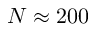<formula> <loc_0><loc_0><loc_500><loc_500>N \approx 2 0 0</formula> 